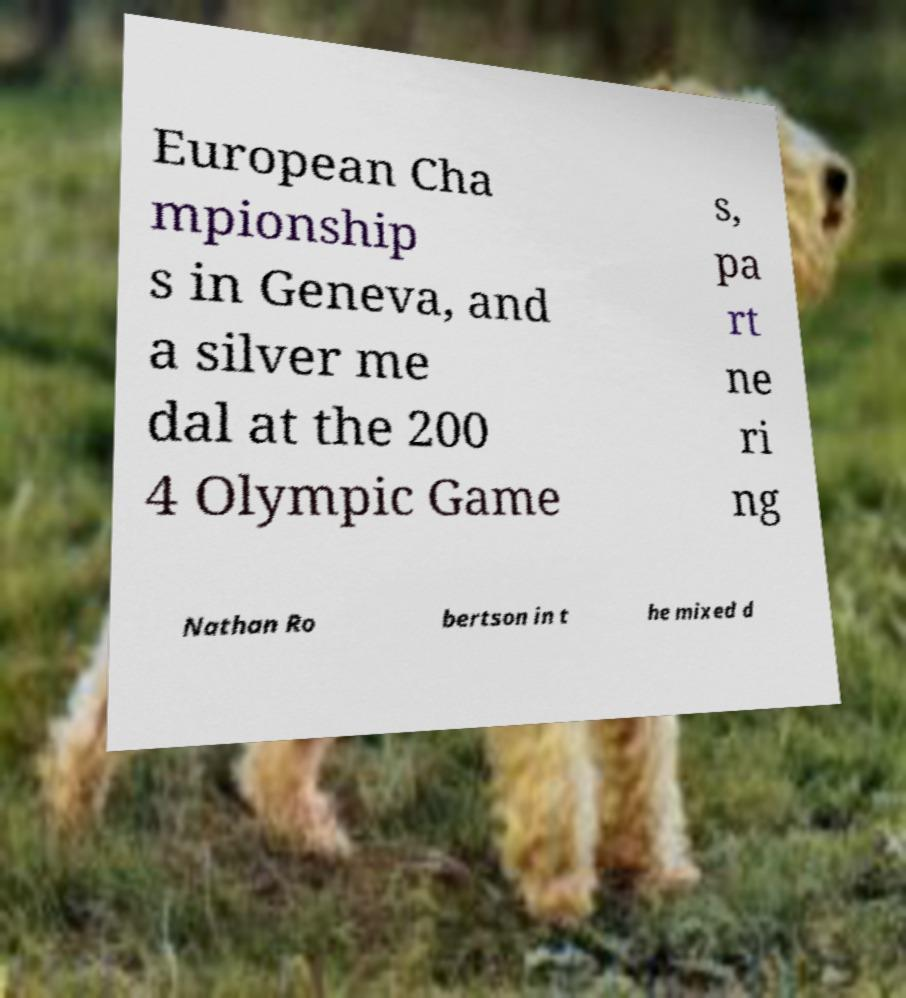Can you accurately transcribe the text from the provided image for me? European Cha mpionship s in Geneva, and a silver me dal at the 200 4 Olympic Game s, pa rt ne ri ng Nathan Ro bertson in t he mixed d 